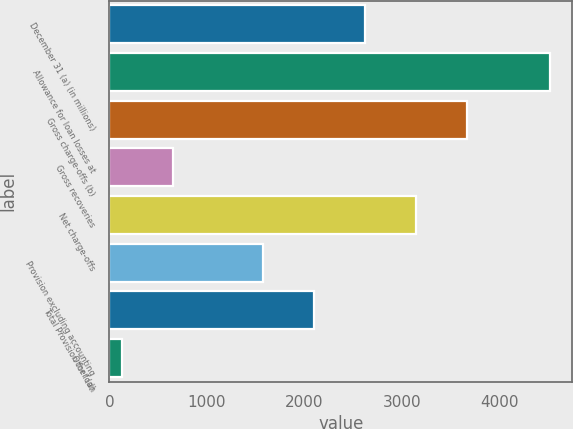Convert chart to OTSL. <chart><loc_0><loc_0><loc_500><loc_500><bar_chart><fcel>December 31 (a) (in millions)<fcel>Allowance for loan losses at<fcel>Gross charge-offs (b)<fcel>Gross recoveries<fcel>Net charge-offs<fcel>Provision excluding accounting<fcel>Total Provision for loan<fcel>Other (d)<nl><fcel>2622.2<fcel>4523<fcel>3665.4<fcel>655.6<fcel>3143.8<fcel>1579<fcel>2100.6<fcel>134<nl></chart> 